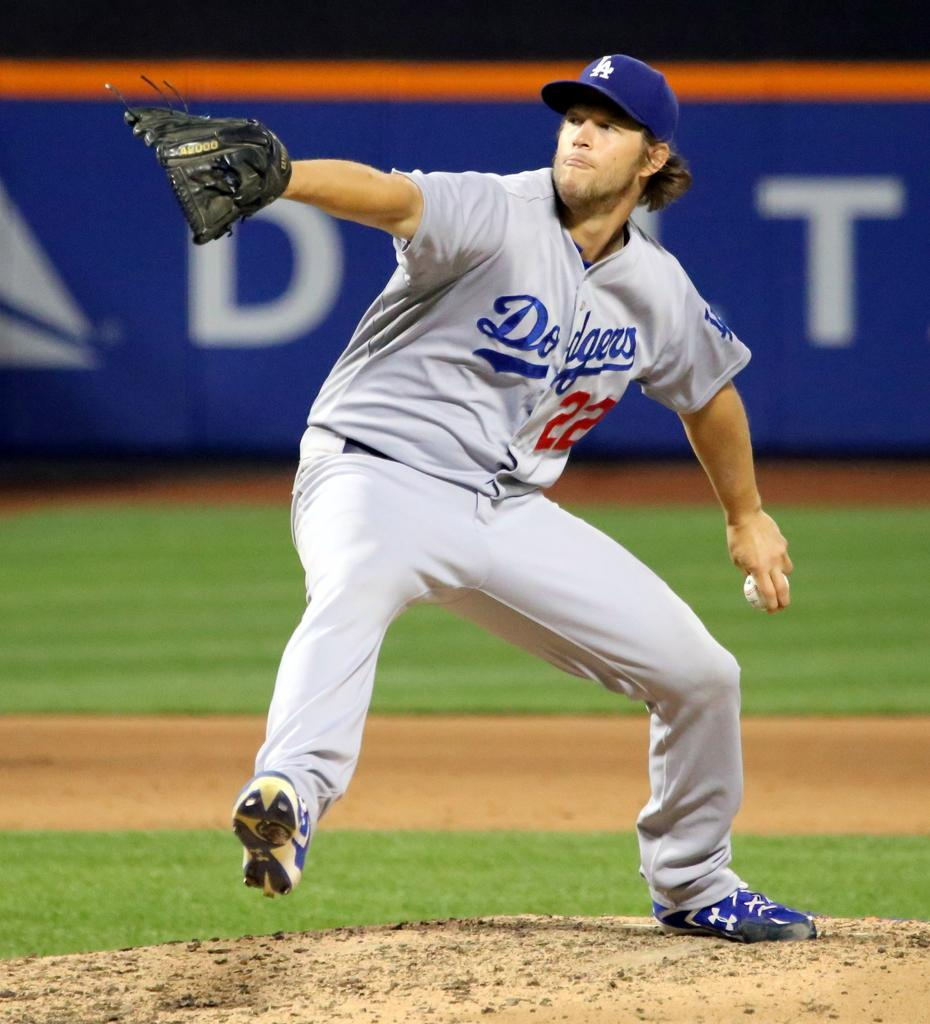<image>
Relay a brief, clear account of the picture shown. The LA Dodgers pitcher is on the mound getting ready to make a pitch. 